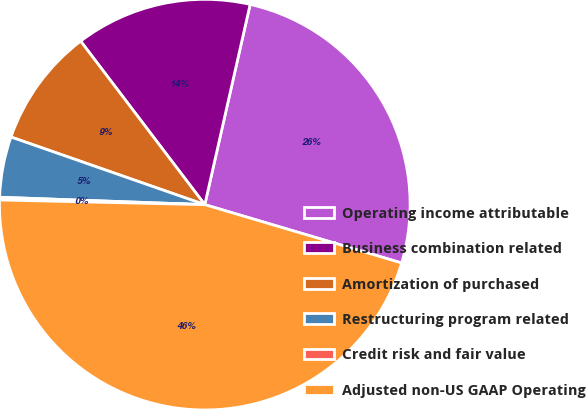<chart> <loc_0><loc_0><loc_500><loc_500><pie_chart><fcel>Operating income attributable<fcel>Business combination related<fcel>Amortization of purchased<fcel>Restructuring program related<fcel>Credit risk and fair value<fcel>Adjusted non-US GAAP Operating<nl><fcel>26.04%<fcel>13.88%<fcel>9.32%<fcel>4.77%<fcel>0.21%<fcel>45.78%<nl></chart> 